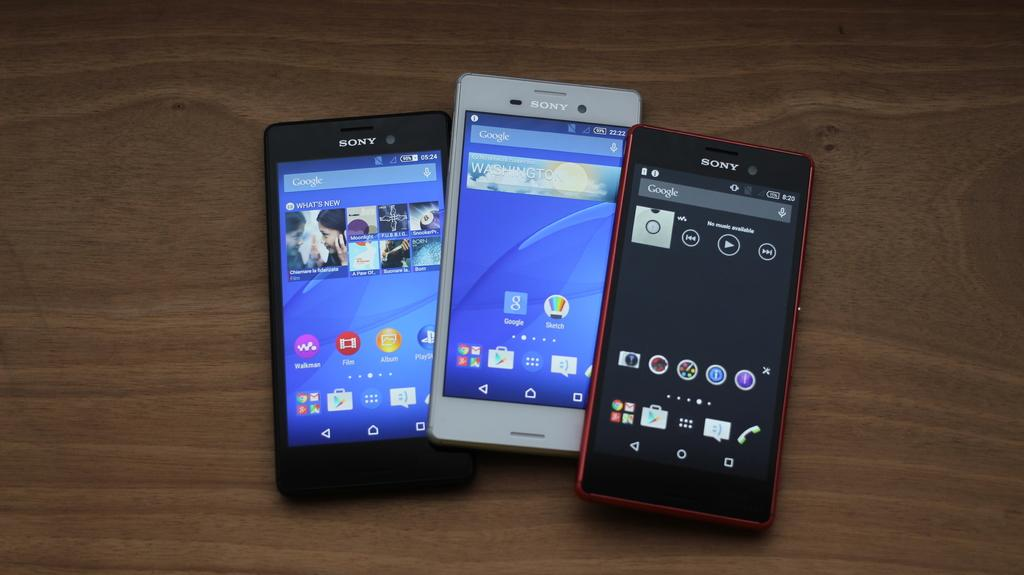<image>
Relay a brief, clear account of the picture shown. ThreeSony cell phones are in shown in different colors. 